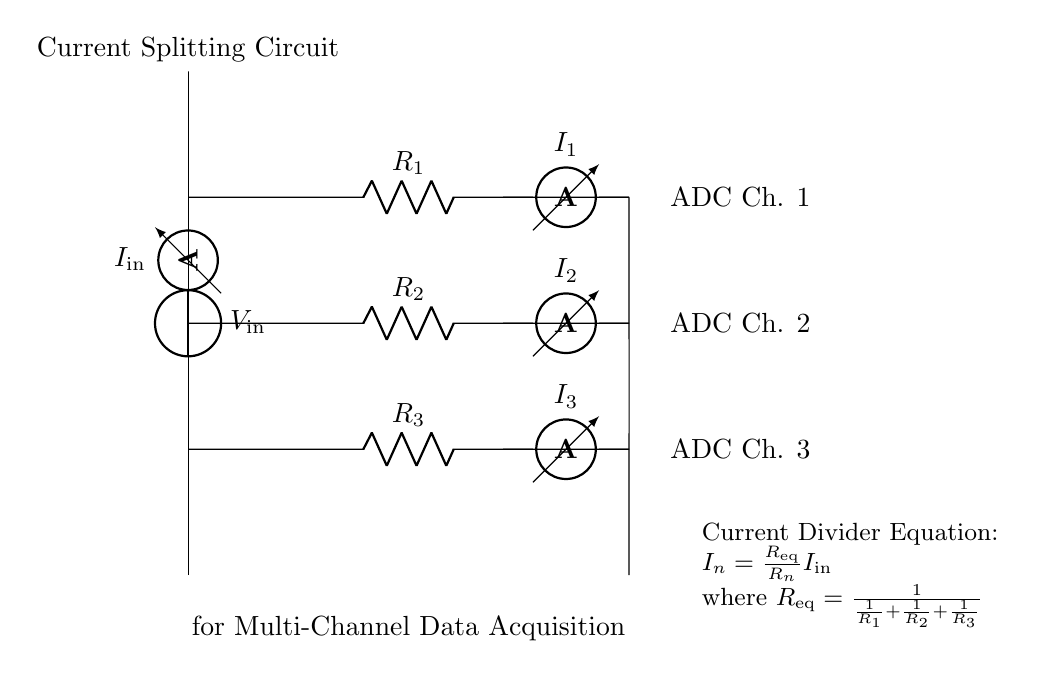What is the input current in the circuit? The input current is denoted as I_in, and it represents the total current entering the circuit before it is divided among the resistors.
Answer: I_in What is the voltage input in the circuit? The voltage input is represented as V_in, which provides the potential difference that drives the input current through the resistors.
Answer: V_in How many ammeters are present in the circuit? There are three ammeters, each measuring the current flowing through R_1, R_2, and R_3 respectively, which allows for monitoring of the current split in the circuit.
Answer: 3 What is the equivalent resistance formula for the resistors in this circuit? The equivalent resistance can be calculated using the formula R_eq = 1 / (1/R_1 + 1/R_2 + 1/R_3), which combines the resistance values of the parallel resistors.
Answer: R_eq = 1 / (1/R_1 + 1/R_2 + 1/R_3) What is the relationship between I_in and I_n for each branch? The relationship is given by the current divider equation: I_n = (R_eq / R_n) * I_in, meaning the current through each resistor is based on its relative resistance to the total equivalent resistance.
Answer: I_n = (R_eq / R_n) * I_in Which component is used to measure the current in each branch? The component used to measure the current in each branch is the ammeter, positioned after each resistor to determine how much current is passing through.
Answer: Ammeter What type of circuit is represented by this diagram? The circuit type is a current divider circuit, which is specifically designed to split input current into multiple output currents based on the resistances of the branches.
Answer: Current Divider 